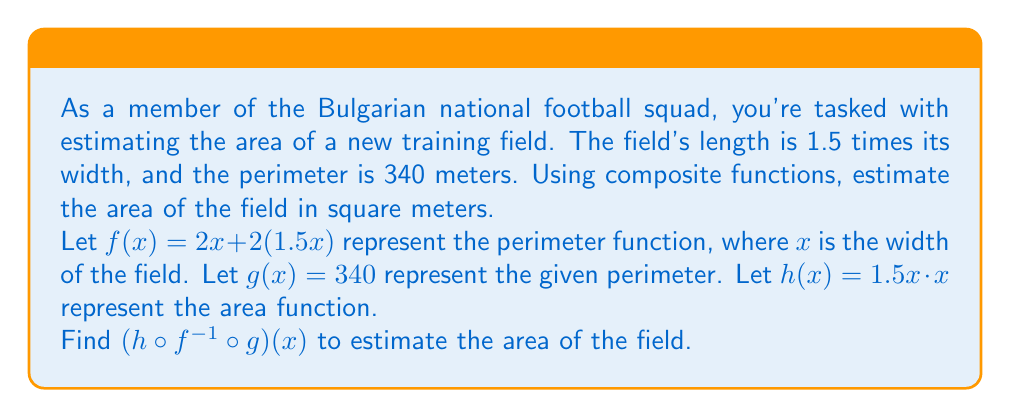Provide a solution to this math problem. Let's approach this step-by-step:

1) First, we need to find $f^{-1}(x)$:
   $f(x) = 2x + 2(1.5x) = 2x + 3x = 5x$
   So, $f^{-1}(x) = \frac{x}{5}$

2) Now, we can compose $f^{-1}$ with $g$:
   $(f^{-1} \circ g)(x) = f^{-1}(340) = \frac{340}{5} = 68$

   This means the width of the field is 68 meters.

3) Finally, we compose $h$ with the result:
   $h(68) = 1.5(68) \cdot 68 = 102 \cdot 68 = 6936$

Therefore, $(h \circ f^{-1} \circ g)(x) = 6936$

To verify:
- Width = 68 m
- Length = 1.5 * 68 = 102 m
- Perimeter = 2(68) + 2(102) = 340 m (matches given perimeter)
- Area = 68 * 102 = 6936 m²
Answer: The estimated area of the football field is 6936 square meters. 